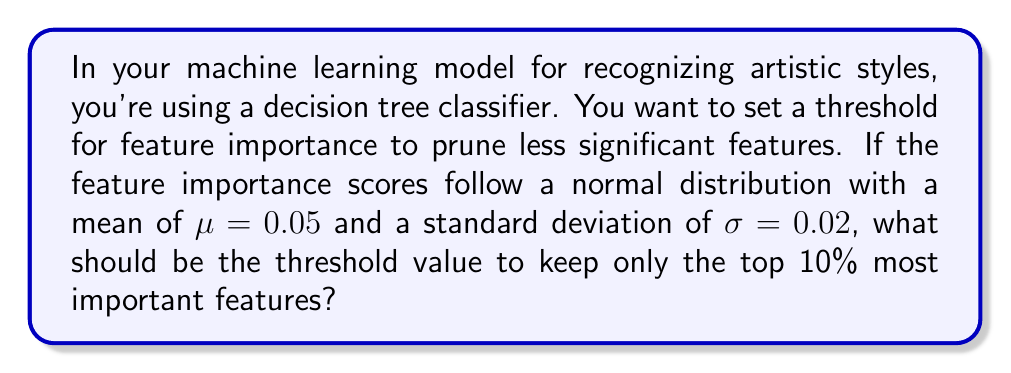Give your solution to this math problem. To solve this problem, we need to use the properties of the normal distribution and the concept of z-scores.

1. We're looking for the threshold that separates the top 10% of features. This means we need to find the value that corresponds to the 90th percentile of the distribution (as we want to keep the top 10%).

2. For a normal distribution, we can use the z-score to find this value. The z-score for the 90th percentile is approximately 1.28 (this is a standard value that can be found in z-score tables).

3. The formula to convert a z-score back to the original scale is:
   
   $$ X = \mu + Z\sigma $$

   Where:
   $X$ is the value we're looking for (the threshold)
   $\mu$ is the mean (0.05)
   $Z$ is the z-score (1.28)
   $\sigma$ is the standard deviation (0.02)

4. Plugging in these values:

   $$ X = 0.05 + 1.28 * 0.02 $$

5. Calculating:
   
   $$ X = 0.05 + 0.0256 = 0.0756 $$

Therefore, the threshold for feature importance should be set at approximately 0.0756.
Answer: 0.0756 